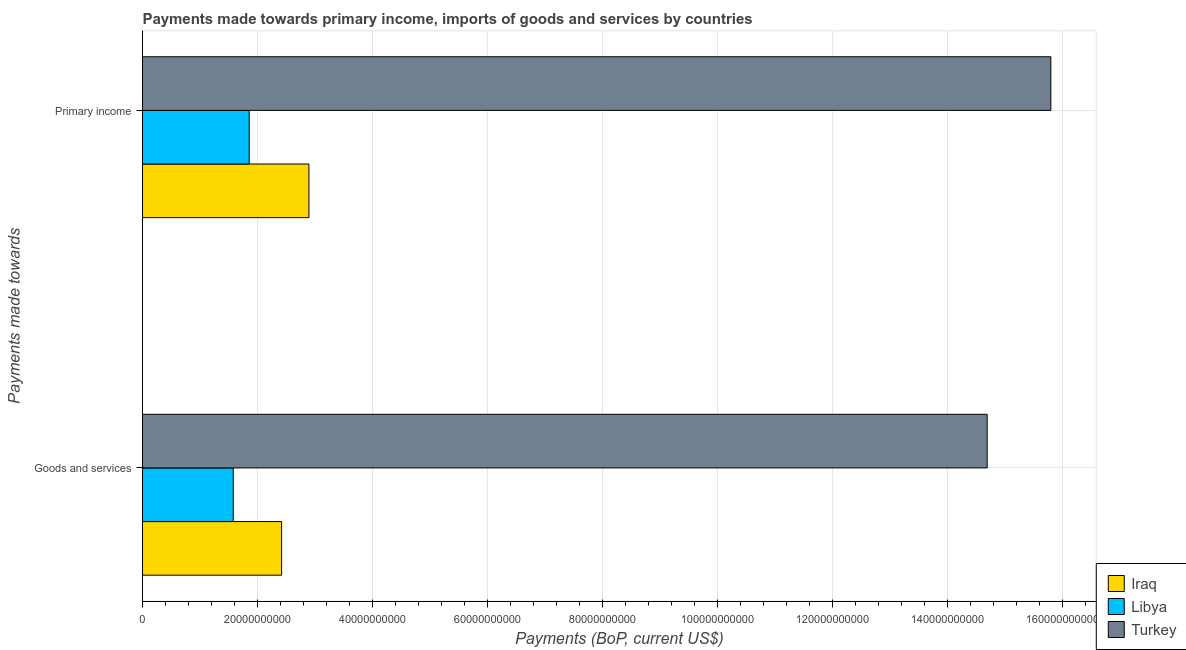How many groups of bars are there?
Provide a succinct answer. 2. Are the number of bars per tick equal to the number of legend labels?
Offer a very short reply. Yes. Are the number of bars on each tick of the Y-axis equal?
Offer a terse response. Yes. How many bars are there on the 1st tick from the bottom?
Offer a very short reply. 3. What is the label of the 1st group of bars from the top?
Offer a terse response. Primary income. What is the payments made towards primary income in Iraq?
Provide a succinct answer. 2.89e+1. Across all countries, what is the maximum payments made towards primary income?
Your answer should be compact. 1.58e+11. Across all countries, what is the minimum payments made towards goods and services?
Make the answer very short. 1.58e+1. In which country was the payments made towards goods and services maximum?
Ensure brevity in your answer.  Turkey. In which country was the payments made towards goods and services minimum?
Your answer should be compact. Libya. What is the total payments made towards primary income in the graph?
Your answer should be compact. 2.06e+11. What is the difference between the payments made towards goods and services in Libya and that in Iraq?
Offer a very short reply. -8.41e+09. What is the difference between the payments made towards primary income in Turkey and the payments made towards goods and services in Libya?
Keep it short and to the point. 1.42e+11. What is the average payments made towards goods and services per country?
Make the answer very short. 6.23e+1. What is the difference between the payments made towards goods and services and payments made towards primary income in Libya?
Provide a short and direct response. -2.78e+09. In how many countries, is the payments made towards goods and services greater than 148000000000 US$?
Make the answer very short. 0. What is the ratio of the payments made towards primary income in Libya to that in Iraq?
Offer a very short reply. 0.64. What does the 3rd bar from the top in Goods and services represents?
Provide a succinct answer. Iraq. What does the 3rd bar from the bottom in Primary income represents?
Provide a succinct answer. Turkey. How many countries are there in the graph?
Provide a succinct answer. 3. What is the difference between two consecutive major ticks on the X-axis?
Provide a succinct answer. 2.00e+1. Are the values on the major ticks of X-axis written in scientific E-notation?
Keep it short and to the point. No. Where does the legend appear in the graph?
Give a very brief answer. Bottom right. How many legend labels are there?
Your answer should be compact. 3. How are the legend labels stacked?
Your answer should be very brief. Vertical. What is the title of the graph?
Offer a very short reply. Payments made towards primary income, imports of goods and services by countries. What is the label or title of the X-axis?
Your response must be concise. Payments (BoP, current US$). What is the label or title of the Y-axis?
Give a very brief answer. Payments made towards. What is the Payments (BoP, current US$) in Iraq in Goods and services?
Make the answer very short. 2.42e+1. What is the Payments (BoP, current US$) of Libya in Goods and services?
Your answer should be very brief. 1.58e+1. What is the Payments (BoP, current US$) of Turkey in Goods and services?
Ensure brevity in your answer.  1.47e+11. What is the Payments (BoP, current US$) of Iraq in Primary income?
Offer a very short reply. 2.89e+1. What is the Payments (BoP, current US$) in Libya in Primary income?
Give a very brief answer. 1.86e+1. What is the Payments (BoP, current US$) of Turkey in Primary income?
Provide a short and direct response. 1.58e+11. Across all Payments made towards, what is the maximum Payments (BoP, current US$) in Iraq?
Provide a succinct answer. 2.89e+1. Across all Payments made towards, what is the maximum Payments (BoP, current US$) in Libya?
Ensure brevity in your answer.  1.86e+1. Across all Payments made towards, what is the maximum Payments (BoP, current US$) of Turkey?
Offer a terse response. 1.58e+11. Across all Payments made towards, what is the minimum Payments (BoP, current US$) of Iraq?
Your answer should be very brief. 2.42e+1. Across all Payments made towards, what is the minimum Payments (BoP, current US$) in Libya?
Make the answer very short. 1.58e+1. Across all Payments made towards, what is the minimum Payments (BoP, current US$) of Turkey?
Provide a succinct answer. 1.47e+11. What is the total Payments (BoP, current US$) of Iraq in the graph?
Give a very brief answer. 5.31e+1. What is the total Payments (BoP, current US$) in Libya in the graph?
Ensure brevity in your answer.  3.43e+1. What is the total Payments (BoP, current US$) of Turkey in the graph?
Provide a short and direct response. 3.05e+11. What is the difference between the Payments (BoP, current US$) in Iraq in Goods and services and that in Primary income?
Offer a terse response. -4.75e+09. What is the difference between the Payments (BoP, current US$) in Libya in Goods and services and that in Primary income?
Your response must be concise. -2.78e+09. What is the difference between the Payments (BoP, current US$) of Turkey in Goods and services and that in Primary income?
Keep it short and to the point. -1.11e+1. What is the difference between the Payments (BoP, current US$) of Iraq in Goods and services and the Payments (BoP, current US$) of Libya in Primary income?
Your answer should be compact. 5.64e+09. What is the difference between the Payments (BoP, current US$) in Iraq in Goods and services and the Payments (BoP, current US$) in Turkey in Primary income?
Provide a short and direct response. -1.34e+11. What is the difference between the Payments (BoP, current US$) of Libya in Goods and services and the Payments (BoP, current US$) of Turkey in Primary income?
Your answer should be compact. -1.42e+11. What is the average Payments (BoP, current US$) of Iraq per Payments made towards?
Your answer should be very brief. 2.66e+1. What is the average Payments (BoP, current US$) in Libya per Payments made towards?
Offer a terse response. 1.72e+1. What is the average Payments (BoP, current US$) of Turkey per Payments made towards?
Offer a terse response. 1.52e+11. What is the difference between the Payments (BoP, current US$) in Iraq and Payments (BoP, current US$) in Libya in Goods and services?
Give a very brief answer. 8.41e+09. What is the difference between the Payments (BoP, current US$) in Iraq and Payments (BoP, current US$) in Turkey in Goods and services?
Ensure brevity in your answer.  -1.23e+11. What is the difference between the Payments (BoP, current US$) in Libya and Payments (BoP, current US$) in Turkey in Goods and services?
Your answer should be very brief. -1.31e+11. What is the difference between the Payments (BoP, current US$) of Iraq and Payments (BoP, current US$) of Libya in Primary income?
Offer a very short reply. 1.04e+1. What is the difference between the Payments (BoP, current US$) in Iraq and Payments (BoP, current US$) in Turkey in Primary income?
Offer a terse response. -1.29e+11. What is the difference between the Payments (BoP, current US$) in Libya and Payments (BoP, current US$) in Turkey in Primary income?
Give a very brief answer. -1.39e+11. What is the ratio of the Payments (BoP, current US$) of Iraq in Goods and services to that in Primary income?
Make the answer very short. 0.84. What is the ratio of the Payments (BoP, current US$) of Libya in Goods and services to that in Primary income?
Your answer should be compact. 0.85. What is the ratio of the Payments (BoP, current US$) in Turkey in Goods and services to that in Primary income?
Ensure brevity in your answer.  0.93. What is the difference between the highest and the second highest Payments (BoP, current US$) in Iraq?
Provide a succinct answer. 4.75e+09. What is the difference between the highest and the second highest Payments (BoP, current US$) in Libya?
Provide a short and direct response. 2.78e+09. What is the difference between the highest and the second highest Payments (BoP, current US$) of Turkey?
Ensure brevity in your answer.  1.11e+1. What is the difference between the highest and the lowest Payments (BoP, current US$) of Iraq?
Provide a short and direct response. 4.75e+09. What is the difference between the highest and the lowest Payments (BoP, current US$) of Libya?
Provide a short and direct response. 2.78e+09. What is the difference between the highest and the lowest Payments (BoP, current US$) in Turkey?
Provide a short and direct response. 1.11e+1. 